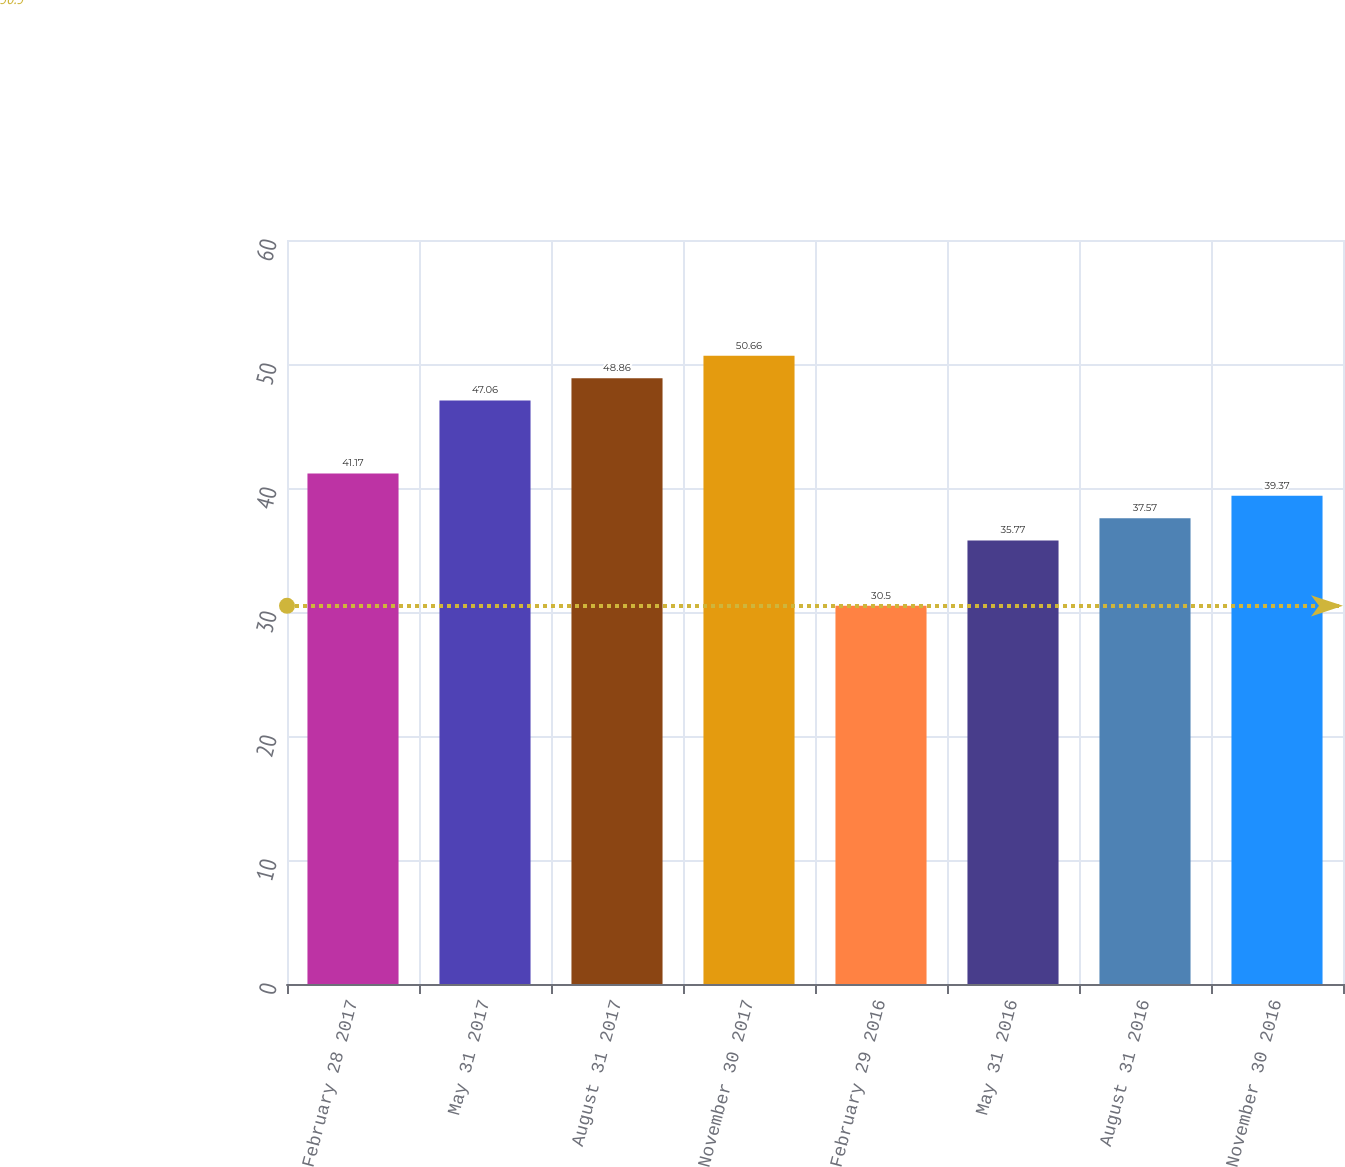Convert chart to OTSL. <chart><loc_0><loc_0><loc_500><loc_500><bar_chart><fcel>February 28 2017<fcel>May 31 2017<fcel>August 31 2017<fcel>November 30 2017<fcel>February 29 2016<fcel>May 31 2016<fcel>August 31 2016<fcel>November 30 2016<nl><fcel>41.17<fcel>47.06<fcel>48.86<fcel>50.66<fcel>30.5<fcel>35.77<fcel>37.57<fcel>39.37<nl></chart> 